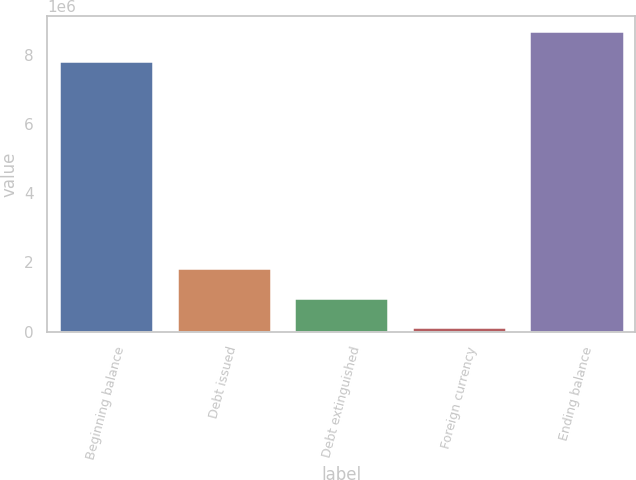<chart> <loc_0><loc_0><loc_500><loc_500><bar_chart><fcel>Beginning balance<fcel>Debt issued<fcel>Debt extinguished<fcel>Foreign currency<fcel>Ending balance<nl><fcel>7.81715e+06<fcel>1.8342e+06<fcel>982753<fcel>131308<fcel>8.6686e+06<nl></chart> 